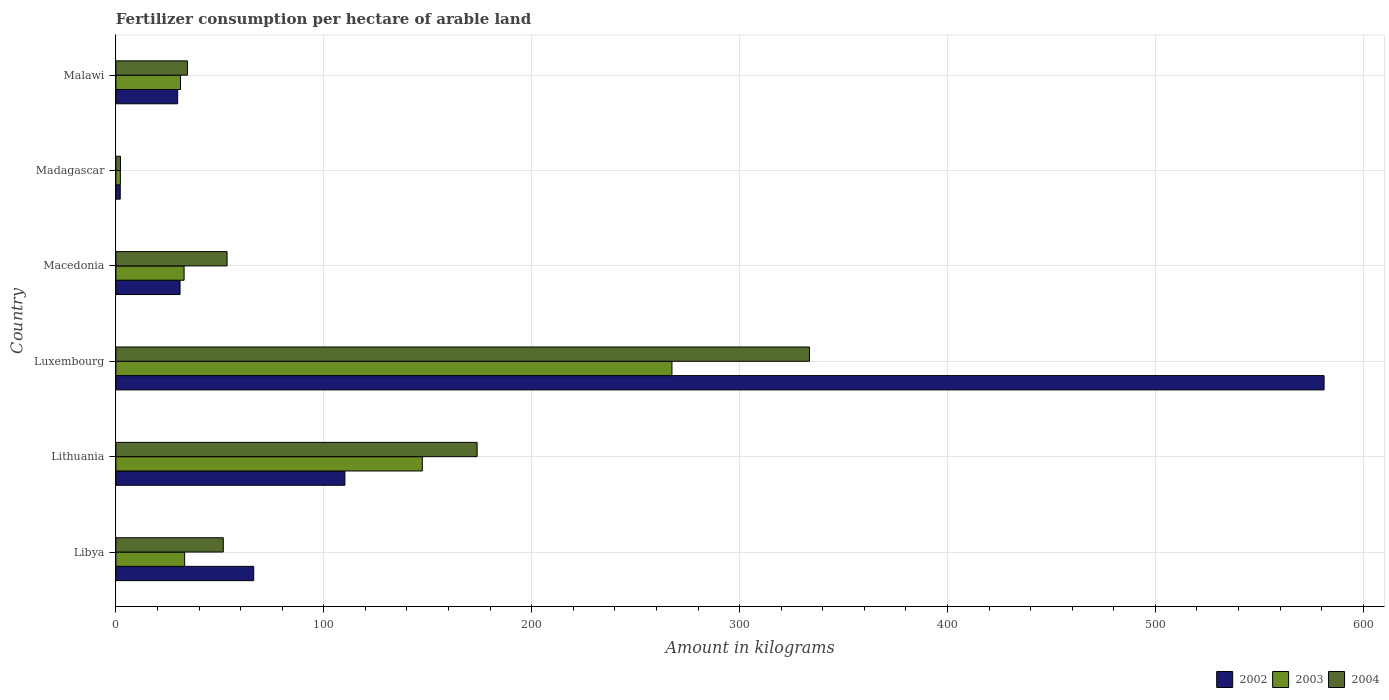How many groups of bars are there?
Your answer should be very brief. 6. How many bars are there on the 3rd tick from the bottom?
Provide a short and direct response. 3. What is the label of the 6th group of bars from the top?
Make the answer very short. Libya. What is the amount of fertilizer consumption in 2002 in Malawi?
Your answer should be very brief. 29.71. Across all countries, what is the maximum amount of fertilizer consumption in 2002?
Provide a short and direct response. 581.15. Across all countries, what is the minimum amount of fertilizer consumption in 2003?
Give a very brief answer. 2.15. In which country was the amount of fertilizer consumption in 2004 maximum?
Your answer should be very brief. Luxembourg. In which country was the amount of fertilizer consumption in 2004 minimum?
Provide a succinct answer. Madagascar. What is the total amount of fertilizer consumption in 2002 in the graph?
Offer a very short reply. 820.26. What is the difference between the amount of fertilizer consumption in 2003 in Luxembourg and that in Macedonia?
Provide a succinct answer. 234.66. What is the difference between the amount of fertilizer consumption in 2003 in Libya and the amount of fertilizer consumption in 2002 in Lithuania?
Keep it short and to the point. -77.09. What is the average amount of fertilizer consumption in 2004 per country?
Provide a short and direct response. 108.19. What is the difference between the amount of fertilizer consumption in 2002 and amount of fertilizer consumption in 2004 in Luxembourg?
Your answer should be compact. 247.53. What is the ratio of the amount of fertilizer consumption in 2002 in Macedonia to that in Malawi?
Make the answer very short. 1.04. Is the amount of fertilizer consumption in 2004 in Libya less than that in Luxembourg?
Offer a very short reply. Yes. Is the difference between the amount of fertilizer consumption in 2002 in Madagascar and Malawi greater than the difference between the amount of fertilizer consumption in 2004 in Madagascar and Malawi?
Your response must be concise. Yes. What is the difference between the highest and the second highest amount of fertilizer consumption in 2004?
Your answer should be compact. 159.85. What is the difference between the highest and the lowest amount of fertilizer consumption in 2002?
Offer a very short reply. 579.05. In how many countries, is the amount of fertilizer consumption in 2003 greater than the average amount of fertilizer consumption in 2003 taken over all countries?
Offer a terse response. 2. Is the sum of the amount of fertilizer consumption in 2002 in Lithuania and Malawi greater than the maximum amount of fertilizer consumption in 2004 across all countries?
Your answer should be very brief. No. Is it the case that in every country, the sum of the amount of fertilizer consumption in 2004 and amount of fertilizer consumption in 2002 is greater than the amount of fertilizer consumption in 2003?
Your answer should be compact. Yes. What is the difference between two consecutive major ticks on the X-axis?
Ensure brevity in your answer.  100. Are the values on the major ticks of X-axis written in scientific E-notation?
Offer a very short reply. No. Does the graph contain any zero values?
Offer a very short reply. No. Does the graph contain grids?
Your answer should be compact. Yes. How many legend labels are there?
Offer a very short reply. 3. What is the title of the graph?
Keep it short and to the point. Fertilizer consumption per hectare of arable land. Does "1970" appear as one of the legend labels in the graph?
Provide a short and direct response. No. What is the label or title of the X-axis?
Your answer should be very brief. Amount in kilograms. What is the Amount in kilograms in 2002 in Libya?
Give a very brief answer. 66.29. What is the Amount in kilograms in 2003 in Libya?
Your response must be concise. 33.07. What is the Amount in kilograms in 2004 in Libya?
Make the answer very short. 51.66. What is the Amount in kilograms in 2002 in Lithuania?
Keep it short and to the point. 110.15. What is the Amount in kilograms of 2003 in Lithuania?
Provide a succinct answer. 147.38. What is the Amount in kilograms in 2004 in Lithuania?
Offer a very short reply. 173.76. What is the Amount in kilograms of 2002 in Luxembourg?
Your answer should be compact. 581.15. What is the Amount in kilograms of 2003 in Luxembourg?
Make the answer very short. 267.47. What is the Amount in kilograms of 2004 in Luxembourg?
Ensure brevity in your answer.  333.61. What is the Amount in kilograms of 2002 in Macedonia?
Make the answer very short. 30.86. What is the Amount in kilograms in 2003 in Macedonia?
Your answer should be compact. 32.8. What is the Amount in kilograms of 2004 in Macedonia?
Ensure brevity in your answer.  53.48. What is the Amount in kilograms in 2002 in Madagascar?
Provide a short and direct response. 2.09. What is the Amount in kilograms in 2003 in Madagascar?
Offer a very short reply. 2.15. What is the Amount in kilograms of 2004 in Madagascar?
Give a very brief answer. 2.2. What is the Amount in kilograms in 2002 in Malawi?
Your response must be concise. 29.71. What is the Amount in kilograms of 2003 in Malawi?
Your answer should be very brief. 31.08. What is the Amount in kilograms of 2004 in Malawi?
Keep it short and to the point. 34.41. Across all countries, what is the maximum Amount in kilograms in 2002?
Your answer should be compact. 581.15. Across all countries, what is the maximum Amount in kilograms of 2003?
Make the answer very short. 267.47. Across all countries, what is the maximum Amount in kilograms of 2004?
Make the answer very short. 333.61. Across all countries, what is the minimum Amount in kilograms in 2002?
Offer a very short reply. 2.09. Across all countries, what is the minimum Amount in kilograms in 2003?
Your answer should be compact. 2.15. Across all countries, what is the minimum Amount in kilograms in 2004?
Make the answer very short. 2.2. What is the total Amount in kilograms in 2002 in the graph?
Offer a terse response. 820.26. What is the total Amount in kilograms in 2003 in the graph?
Provide a succinct answer. 513.95. What is the total Amount in kilograms of 2004 in the graph?
Provide a short and direct response. 649.12. What is the difference between the Amount in kilograms in 2002 in Libya and that in Lithuania?
Offer a terse response. -43.86. What is the difference between the Amount in kilograms in 2003 in Libya and that in Lithuania?
Your answer should be very brief. -114.31. What is the difference between the Amount in kilograms in 2004 in Libya and that in Lithuania?
Make the answer very short. -122.1. What is the difference between the Amount in kilograms of 2002 in Libya and that in Luxembourg?
Offer a very short reply. -514.85. What is the difference between the Amount in kilograms of 2003 in Libya and that in Luxembourg?
Provide a short and direct response. -234.4. What is the difference between the Amount in kilograms of 2004 in Libya and that in Luxembourg?
Your answer should be compact. -281.96. What is the difference between the Amount in kilograms in 2002 in Libya and that in Macedonia?
Make the answer very short. 35.43. What is the difference between the Amount in kilograms in 2003 in Libya and that in Macedonia?
Provide a short and direct response. 0.27. What is the difference between the Amount in kilograms of 2004 in Libya and that in Macedonia?
Give a very brief answer. -1.82. What is the difference between the Amount in kilograms of 2002 in Libya and that in Madagascar?
Keep it short and to the point. 64.2. What is the difference between the Amount in kilograms of 2003 in Libya and that in Madagascar?
Give a very brief answer. 30.92. What is the difference between the Amount in kilograms of 2004 in Libya and that in Madagascar?
Offer a very short reply. 49.45. What is the difference between the Amount in kilograms of 2002 in Libya and that in Malawi?
Your answer should be compact. 36.58. What is the difference between the Amount in kilograms in 2003 in Libya and that in Malawi?
Provide a succinct answer. 1.99. What is the difference between the Amount in kilograms in 2004 in Libya and that in Malawi?
Your answer should be compact. 17.25. What is the difference between the Amount in kilograms in 2002 in Lithuania and that in Luxembourg?
Give a very brief answer. -470.99. What is the difference between the Amount in kilograms of 2003 in Lithuania and that in Luxembourg?
Your response must be concise. -120.08. What is the difference between the Amount in kilograms of 2004 in Lithuania and that in Luxembourg?
Ensure brevity in your answer.  -159.85. What is the difference between the Amount in kilograms of 2002 in Lithuania and that in Macedonia?
Offer a very short reply. 79.3. What is the difference between the Amount in kilograms of 2003 in Lithuania and that in Macedonia?
Your answer should be very brief. 114.58. What is the difference between the Amount in kilograms in 2004 in Lithuania and that in Macedonia?
Provide a short and direct response. 120.28. What is the difference between the Amount in kilograms in 2002 in Lithuania and that in Madagascar?
Give a very brief answer. 108.06. What is the difference between the Amount in kilograms in 2003 in Lithuania and that in Madagascar?
Provide a succinct answer. 145.24. What is the difference between the Amount in kilograms of 2004 in Lithuania and that in Madagascar?
Keep it short and to the point. 171.56. What is the difference between the Amount in kilograms in 2002 in Lithuania and that in Malawi?
Ensure brevity in your answer.  80.44. What is the difference between the Amount in kilograms of 2003 in Lithuania and that in Malawi?
Give a very brief answer. 116.31. What is the difference between the Amount in kilograms in 2004 in Lithuania and that in Malawi?
Your answer should be very brief. 139.35. What is the difference between the Amount in kilograms of 2002 in Luxembourg and that in Macedonia?
Your response must be concise. 550.29. What is the difference between the Amount in kilograms of 2003 in Luxembourg and that in Macedonia?
Provide a short and direct response. 234.66. What is the difference between the Amount in kilograms in 2004 in Luxembourg and that in Macedonia?
Make the answer very short. 280.13. What is the difference between the Amount in kilograms in 2002 in Luxembourg and that in Madagascar?
Keep it short and to the point. 579.05. What is the difference between the Amount in kilograms of 2003 in Luxembourg and that in Madagascar?
Your answer should be very brief. 265.32. What is the difference between the Amount in kilograms of 2004 in Luxembourg and that in Madagascar?
Make the answer very short. 331.41. What is the difference between the Amount in kilograms in 2002 in Luxembourg and that in Malawi?
Your answer should be compact. 551.43. What is the difference between the Amount in kilograms of 2003 in Luxembourg and that in Malawi?
Provide a succinct answer. 236.39. What is the difference between the Amount in kilograms in 2004 in Luxembourg and that in Malawi?
Your answer should be compact. 299.21. What is the difference between the Amount in kilograms of 2002 in Macedonia and that in Madagascar?
Ensure brevity in your answer.  28.77. What is the difference between the Amount in kilograms of 2003 in Macedonia and that in Madagascar?
Your answer should be compact. 30.66. What is the difference between the Amount in kilograms in 2004 in Macedonia and that in Madagascar?
Give a very brief answer. 51.28. What is the difference between the Amount in kilograms of 2002 in Macedonia and that in Malawi?
Your answer should be compact. 1.15. What is the difference between the Amount in kilograms of 2003 in Macedonia and that in Malawi?
Your answer should be very brief. 1.73. What is the difference between the Amount in kilograms of 2004 in Macedonia and that in Malawi?
Offer a terse response. 19.08. What is the difference between the Amount in kilograms of 2002 in Madagascar and that in Malawi?
Offer a terse response. -27.62. What is the difference between the Amount in kilograms of 2003 in Madagascar and that in Malawi?
Offer a terse response. -28.93. What is the difference between the Amount in kilograms of 2004 in Madagascar and that in Malawi?
Your answer should be compact. -32.2. What is the difference between the Amount in kilograms of 2002 in Libya and the Amount in kilograms of 2003 in Lithuania?
Provide a succinct answer. -81.09. What is the difference between the Amount in kilograms in 2002 in Libya and the Amount in kilograms in 2004 in Lithuania?
Provide a succinct answer. -107.47. What is the difference between the Amount in kilograms in 2003 in Libya and the Amount in kilograms in 2004 in Lithuania?
Ensure brevity in your answer.  -140.69. What is the difference between the Amount in kilograms in 2002 in Libya and the Amount in kilograms in 2003 in Luxembourg?
Provide a short and direct response. -201.18. What is the difference between the Amount in kilograms of 2002 in Libya and the Amount in kilograms of 2004 in Luxembourg?
Provide a short and direct response. -267.32. What is the difference between the Amount in kilograms in 2003 in Libya and the Amount in kilograms in 2004 in Luxembourg?
Offer a terse response. -300.54. What is the difference between the Amount in kilograms of 2002 in Libya and the Amount in kilograms of 2003 in Macedonia?
Your answer should be very brief. 33.49. What is the difference between the Amount in kilograms in 2002 in Libya and the Amount in kilograms in 2004 in Macedonia?
Keep it short and to the point. 12.81. What is the difference between the Amount in kilograms of 2003 in Libya and the Amount in kilograms of 2004 in Macedonia?
Your answer should be compact. -20.41. What is the difference between the Amount in kilograms of 2002 in Libya and the Amount in kilograms of 2003 in Madagascar?
Keep it short and to the point. 64.14. What is the difference between the Amount in kilograms in 2002 in Libya and the Amount in kilograms in 2004 in Madagascar?
Keep it short and to the point. 64.09. What is the difference between the Amount in kilograms in 2003 in Libya and the Amount in kilograms in 2004 in Madagascar?
Keep it short and to the point. 30.87. What is the difference between the Amount in kilograms in 2002 in Libya and the Amount in kilograms in 2003 in Malawi?
Your answer should be compact. 35.21. What is the difference between the Amount in kilograms of 2002 in Libya and the Amount in kilograms of 2004 in Malawi?
Your response must be concise. 31.89. What is the difference between the Amount in kilograms of 2003 in Libya and the Amount in kilograms of 2004 in Malawi?
Ensure brevity in your answer.  -1.34. What is the difference between the Amount in kilograms of 2002 in Lithuania and the Amount in kilograms of 2003 in Luxembourg?
Make the answer very short. -157.31. What is the difference between the Amount in kilograms of 2002 in Lithuania and the Amount in kilograms of 2004 in Luxembourg?
Give a very brief answer. -223.46. What is the difference between the Amount in kilograms in 2003 in Lithuania and the Amount in kilograms in 2004 in Luxembourg?
Your answer should be compact. -186.23. What is the difference between the Amount in kilograms of 2002 in Lithuania and the Amount in kilograms of 2003 in Macedonia?
Your answer should be compact. 77.35. What is the difference between the Amount in kilograms of 2002 in Lithuania and the Amount in kilograms of 2004 in Macedonia?
Ensure brevity in your answer.  56.67. What is the difference between the Amount in kilograms of 2003 in Lithuania and the Amount in kilograms of 2004 in Macedonia?
Provide a short and direct response. 93.9. What is the difference between the Amount in kilograms in 2002 in Lithuania and the Amount in kilograms in 2003 in Madagascar?
Keep it short and to the point. 108.01. What is the difference between the Amount in kilograms in 2002 in Lithuania and the Amount in kilograms in 2004 in Madagascar?
Provide a succinct answer. 107.95. What is the difference between the Amount in kilograms in 2003 in Lithuania and the Amount in kilograms in 2004 in Madagascar?
Keep it short and to the point. 145.18. What is the difference between the Amount in kilograms in 2002 in Lithuania and the Amount in kilograms in 2003 in Malawi?
Give a very brief answer. 79.08. What is the difference between the Amount in kilograms of 2002 in Lithuania and the Amount in kilograms of 2004 in Malawi?
Make the answer very short. 75.75. What is the difference between the Amount in kilograms of 2003 in Lithuania and the Amount in kilograms of 2004 in Malawi?
Offer a very short reply. 112.98. What is the difference between the Amount in kilograms of 2002 in Luxembourg and the Amount in kilograms of 2003 in Macedonia?
Provide a short and direct response. 548.34. What is the difference between the Amount in kilograms in 2002 in Luxembourg and the Amount in kilograms in 2004 in Macedonia?
Your response must be concise. 527.66. What is the difference between the Amount in kilograms in 2003 in Luxembourg and the Amount in kilograms in 2004 in Macedonia?
Give a very brief answer. 213.99. What is the difference between the Amount in kilograms of 2002 in Luxembourg and the Amount in kilograms of 2003 in Madagascar?
Provide a succinct answer. 579. What is the difference between the Amount in kilograms in 2002 in Luxembourg and the Amount in kilograms in 2004 in Madagascar?
Offer a very short reply. 578.94. What is the difference between the Amount in kilograms of 2003 in Luxembourg and the Amount in kilograms of 2004 in Madagascar?
Your answer should be compact. 265.26. What is the difference between the Amount in kilograms of 2002 in Luxembourg and the Amount in kilograms of 2003 in Malawi?
Provide a succinct answer. 550.07. What is the difference between the Amount in kilograms of 2002 in Luxembourg and the Amount in kilograms of 2004 in Malawi?
Make the answer very short. 546.74. What is the difference between the Amount in kilograms of 2003 in Luxembourg and the Amount in kilograms of 2004 in Malawi?
Keep it short and to the point. 233.06. What is the difference between the Amount in kilograms of 2002 in Macedonia and the Amount in kilograms of 2003 in Madagascar?
Your answer should be compact. 28.71. What is the difference between the Amount in kilograms of 2002 in Macedonia and the Amount in kilograms of 2004 in Madagascar?
Provide a succinct answer. 28.66. What is the difference between the Amount in kilograms in 2003 in Macedonia and the Amount in kilograms in 2004 in Madagascar?
Keep it short and to the point. 30.6. What is the difference between the Amount in kilograms of 2002 in Macedonia and the Amount in kilograms of 2003 in Malawi?
Ensure brevity in your answer.  -0.22. What is the difference between the Amount in kilograms of 2002 in Macedonia and the Amount in kilograms of 2004 in Malawi?
Your answer should be compact. -3.55. What is the difference between the Amount in kilograms in 2003 in Macedonia and the Amount in kilograms in 2004 in Malawi?
Ensure brevity in your answer.  -1.6. What is the difference between the Amount in kilograms in 2002 in Madagascar and the Amount in kilograms in 2003 in Malawi?
Provide a succinct answer. -28.98. What is the difference between the Amount in kilograms of 2002 in Madagascar and the Amount in kilograms of 2004 in Malawi?
Your answer should be compact. -32.31. What is the difference between the Amount in kilograms of 2003 in Madagascar and the Amount in kilograms of 2004 in Malawi?
Provide a short and direct response. -32.26. What is the average Amount in kilograms in 2002 per country?
Offer a very short reply. 136.71. What is the average Amount in kilograms in 2003 per country?
Keep it short and to the point. 85.66. What is the average Amount in kilograms in 2004 per country?
Your answer should be compact. 108.19. What is the difference between the Amount in kilograms of 2002 and Amount in kilograms of 2003 in Libya?
Your answer should be compact. 33.22. What is the difference between the Amount in kilograms in 2002 and Amount in kilograms in 2004 in Libya?
Make the answer very short. 14.64. What is the difference between the Amount in kilograms of 2003 and Amount in kilograms of 2004 in Libya?
Your answer should be very brief. -18.59. What is the difference between the Amount in kilograms of 2002 and Amount in kilograms of 2003 in Lithuania?
Your response must be concise. -37.23. What is the difference between the Amount in kilograms of 2002 and Amount in kilograms of 2004 in Lithuania?
Provide a succinct answer. -63.61. What is the difference between the Amount in kilograms in 2003 and Amount in kilograms in 2004 in Lithuania?
Keep it short and to the point. -26.38. What is the difference between the Amount in kilograms in 2002 and Amount in kilograms in 2003 in Luxembourg?
Your answer should be very brief. 313.68. What is the difference between the Amount in kilograms of 2002 and Amount in kilograms of 2004 in Luxembourg?
Your response must be concise. 247.53. What is the difference between the Amount in kilograms in 2003 and Amount in kilograms in 2004 in Luxembourg?
Keep it short and to the point. -66.15. What is the difference between the Amount in kilograms of 2002 and Amount in kilograms of 2003 in Macedonia?
Offer a terse response. -1.95. What is the difference between the Amount in kilograms in 2002 and Amount in kilograms in 2004 in Macedonia?
Keep it short and to the point. -22.62. What is the difference between the Amount in kilograms of 2003 and Amount in kilograms of 2004 in Macedonia?
Your answer should be compact. -20.68. What is the difference between the Amount in kilograms of 2002 and Amount in kilograms of 2003 in Madagascar?
Give a very brief answer. -0.05. What is the difference between the Amount in kilograms of 2002 and Amount in kilograms of 2004 in Madagascar?
Give a very brief answer. -0.11. What is the difference between the Amount in kilograms in 2003 and Amount in kilograms in 2004 in Madagascar?
Offer a terse response. -0.05. What is the difference between the Amount in kilograms of 2002 and Amount in kilograms of 2003 in Malawi?
Your answer should be compact. -1.36. What is the difference between the Amount in kilograms in 2002 and Amount in kilograms in 2004 in Malawi?
Give a very brief answer. -4.69. What is the difference between the Amount in kilograms of 2003 and Amount in kilograms of 2004 in Malawi?
Keep it short and to the point. -3.33. What is the ratio of the Amount in kilograms in 2002 in Libya to that in Lithuania?
Give a very brief answer. 0.6. What is the ratio of the Amount in kilograms in 2003 in Libya to that in Lithuania?
Offer a terse response. 0.22. What is the ratio of the Amount in kilograms in 2004 in Libya to that in Lithuania?
Your answer should be compact. 0.3. What is the ratio of the Amount in kilograms in 2002 in Libya to that in Luxembourg?
Offer a very short reply. 0.11. What is the ratio of the Amount in kilograms of 2003 in Libya to that in Luxembourg?
Offer a very short reply. 0.12. What is the ratio of the Amount in kilograms in 2004 in Libya to that in Luxembourg?
Provide a short and direct response. 0.15. What is the ratio of the Amount in kilograms of 2002 in Libya to that in Macedonia?
Keep it short and to the point. 2.15. What is the ratio of the Amount in kilograms in 2004 in Libya to that in Macedonia?
Your answer should be very brief. 0.97. What is the ratio of the Amount in kilograms in 2002 in Libya to that in Madagascar?
Your answer should be compact. 31.65. What is the ratio of the Amount in kilograms in 2003 in Libya to that in Madagascar?
Your answer should be very brief. 15.39. What is the ratio of the Amount in kilograms in 2004 in Libya to that in Madagascar?
Provide a succinct answer. 23.45. What is the ratio of the Amount in kilograms of 2002 in Libya to that in Malawi?
Your response must be concise. 2.23. What is the ratio of the Amount in kilograms of 2003 in Libya to that in Malawi?
Provide a short and direct response. 1.06. What is the ratio of the Amount in kilograms in 2004 in Libya to that in Malawi?
Provide a short and direct response. 1.5. What is the ratio of the Amount in kilograms in 2002 in Lithuania to that in Luxembourg?
Your answer should be very brief. 0.19. What is the ratio of the Amount in kilograms in 2003 in Lithuania to that in Luxembourg?
Your response must be concise. 0.55. What is the ratio of the Amount in kilograms in 2004 in Lithuania to that in Luxembourg?
Your response must be concise. 0.52. What is the ratio of the Amount in kilograms of 2002 in Lithuania to that in Macedonia?
Offer a very short reply. 3.57. What is the ratio of the Amount in kilograms in 2003 in Lithuania to that in Macedonia?
Keep it short and to the point. 4.49. What is the ratio of the Amount in kilograms of 2004 in Lithuania to that in Macedonia?
Keep it short and to the point. 3.25. What is the ratio of the Amount in kilograms in 2002 in Lithuania to that in Madagascar?
Your response must be concise. 52.6. What is the ratio of the Amount in kilograms in 2003 in Lithuania to that in Madagascar?
Offer a terse response. 68.61. What is the ratio of the Amount in kilograms in 2004 in Lithuania to that in Madagascar?
Your answer should be compact. 78.87. What is the ratio of the Amount in kilograms of 2002 in Lithuania to that in Malawi?
Offer a terse response. 3.71. What is the ratio of the Amount in kilograms in 2003 in Lithuania to that in Malawi?
Your response must be concise. 4.74. What is the ratio of the Amount in kilograms in 2004 in Lithuania to that in Malawi?
Offer a terse response. 5.05. What is the ratio of the Amount in kilograms of 2002 in Luxembourg to that in Macedonia?
Offer a very short reply. 18.83. What is the ratio of the Amount in kilograms in 2003 in Luxembourg to that in Macedonia?
Give a very brief answer. 8.15. What is the ratio of the Amount in kilograms of 2004 in Luxembourg to that in Macedonia?
Your response must be concise. 6.24. What is the ratio of the Amount in kilograms in 2002 in Luxembourg to that in Madagascar?
Provide a succinct answer. 277.5. What is the ratio of the Amount in kilograms in 2003 in Luxembourg to that in Madagascar?
Offer a very short reply. 124.51. What is the ratio of the Amount in kilograms of 2004 in Luxembourg to that in Madagascar?
Offer a terse response. 151.43. What is the ratio of the Amount in kilograms in 2002 in Luxembourg to that in Malawi?
Your answer should be very brief. 19.56. What is the ratio of the Amount in kilograms of 2003 in Luxembourg to that in Malawi?
Offer a very short reply. 8.61. What is the ratio of the Amount in kilograms of 2004 in Luxembourg to that in Malawi?
Offer a terse response. 9.7. What is the ratio of the Amount in kilograms of 2002 in Macedonia to that in Madagascar?
Keep it short and to the point. 14.74. What is the ratio of the Amount in kilograms in 2003 in Macedonia to that in Madagascar?
Your response must be concise. 15.27. What is the ratio of the Amount in kilograms in 2004 in Macedonia to that in Madagascar?
Your answer should be very brief. 24.28. What is the ratio of the Amount in kilograms in 2002 in Macedonia to that in Malawi?
Give a very brief answer. 1.04. What is the ratio of the Amount in kilograms in 2003 in Macedonia to that in Malawi?
Give a very brief answer. 1.06. What is the ratio of the Amount in kilograms of 2004 in Macedonia to that in Malawi?
Give a very brief answer. 1.55. What is the ratio of the Amount in kilograms in 2002 in Madagascar to that in Malawi?
Your answer should be very brief. 0.07. What is the ratio of the Amount in kilograms of 2003 in Madagascar to that in Malawi?
Provide a succinct answer. 0.07. What is the ratio of the Amount in kilograms in 2004 in Madagascar to that in Malawi?
Give a very brief answer. 0.06. What is the difference between the highest and the second highest Amount in kilograms in 2002?
Give a very brief answer. 470.99. What is the difference between the highest and the second highest Amount in kilograms in 2003?
Ensure brevity in your answer.  120.08. What is the difference between the highest and the second highest Amount in kilograms in 2004?
Offer a terse response. 159.85. What is the difference between the highest and the lowest Amount in kilograms of 2002?
Offer a terse response. 579.05. What is the difference between the highest and the lowest Amount in kilograms of 2003?
Keep it short and to the point. 265.32. What is the difference between the highest and the lowest Amount in kilograms in 2004?
Give a very brief answer. 331.41. 